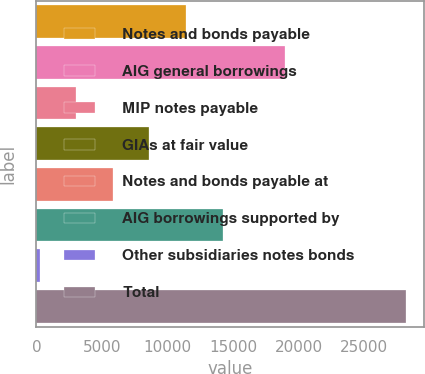Convert chart. <chart><loc_0><loc_0><loc_500><loc_500><bar_chart><fcel>Notes and bonds payable<fcel>AIG general borrowings<fcel>MIP notes payable<fcel>GIAs at fair value<fcel>Notes and bonds payable at<fcel>AIG borrowings supported by<fcel>Other subsidiaries notes bonds<fcel>Total<nl><fcel>11406.2<fcel>18976<fcel>3032.3<fcel>8614.9<fcel>5823.6<fcel>14197.5<fcel>241<fcel>28154<nl></chart> 